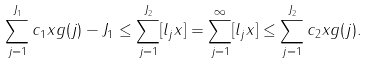<formula> <loc_0><loc_0><loc_500><loc_500>\sum _ { j = 1 } ^ { J _ { 1 } } c _ { 1 } x g ( j ) - J _ { 1 } \leq \sum _ { j = 1 } ^ { J _ { 2 } } [ l _ { j } x ] = \sum _ { j = 1 } ^ { \infty } [ l _ { j } x ] \leq \sum _ { j = 1 } ^ { J _ { 2 } } c _ { 2 } x g ( j ) .</formula> 